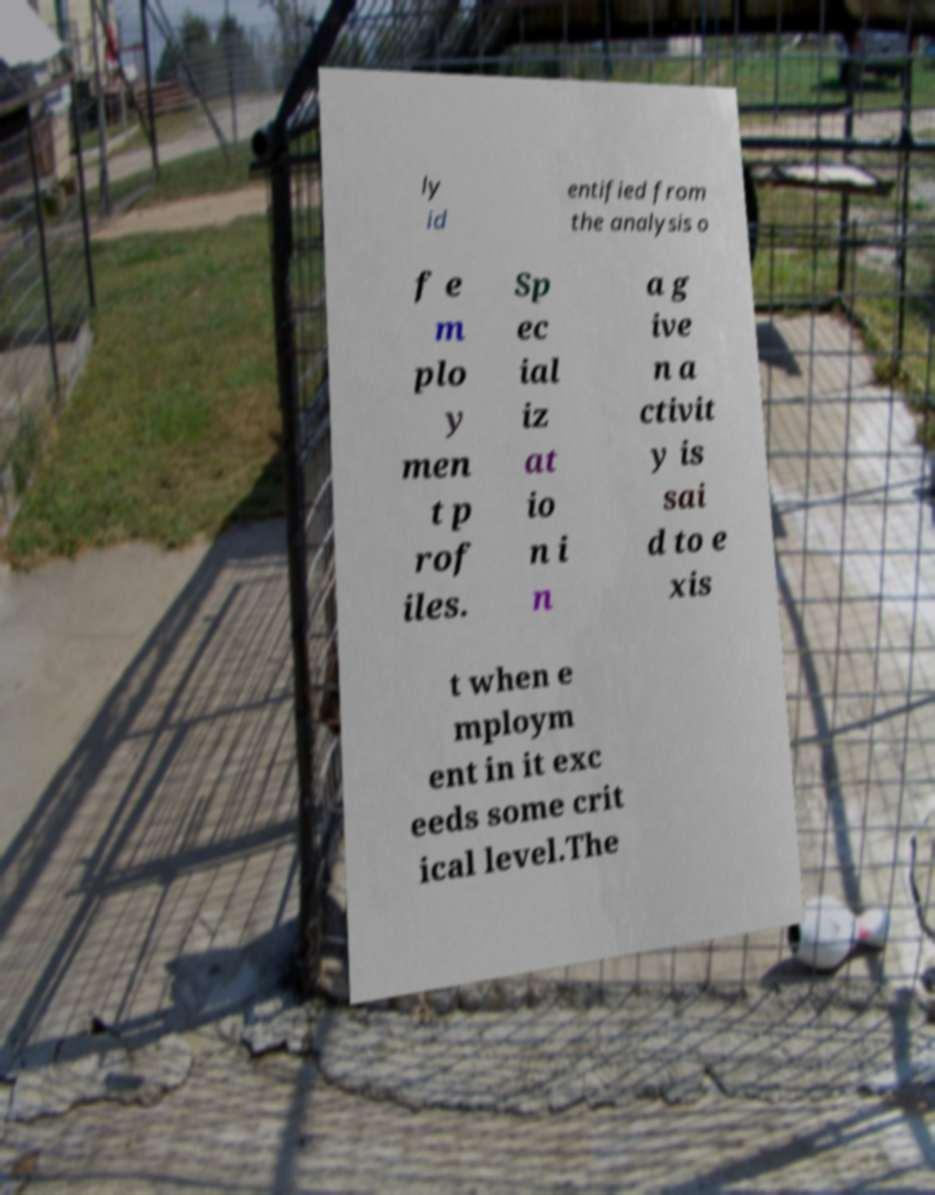Please read and relay the text visible in this image. What does it say? ly id entified from the analysis o f e m plo y men t p rof iles. Sp ec ial iz at io n i n a g ive n a ctivit y is sai d to e xis t when e mploym ent in it exc eeds some crit ical level.The 